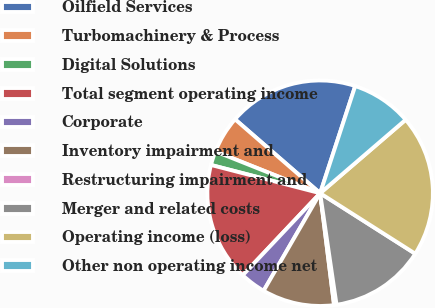<chart> <loc_0><loc_0><loc_500><loc_500><pie_chart><fcel>Oilfield Services<fcel>Turbomachinery & Process<fcel>Digital Solutions<fcel>Total segment operating income<fcel>Corporate<fcel>Inventory impairment and<fcel>Restructuring impairment and<fcel>Merger and related costs<fcel>Operating income (loss)<fcel>Other non operating income net<nl><fcel>18.65%<fcel>5.34%<fcel>2.01%<fcel>16.99%<fcel>3.68%<fcel>10.33%<fcel>0.35%<fcel>13.66%<fcel>20.31%<fcel>8.67%<nl></chart> 